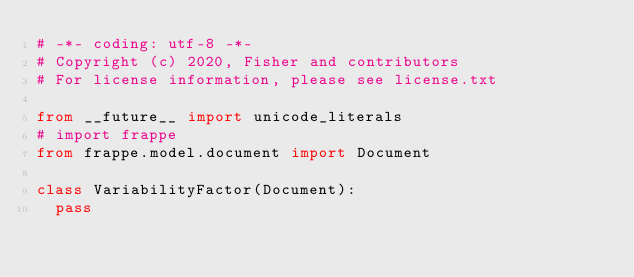Convert code to text. <code><loc_0><loc_0><loc_500><loc_500><_Python_># -*- coding: utf-8 -*-
# Copyright (c) 2020, Fisher and contributors
# For license information, please see license.txt

from __future__ import unicode_literals
# import frappe
from frappe.model.document import Document

class VariabilityFactor(Document):
	pass
</code> 